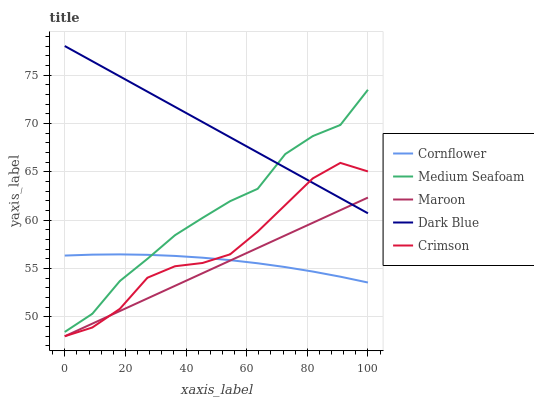Does Maroon have the minimum area under the curve?
Answer yes or no. Yes. Does Dark Blue have the maximum area under the curve?
Answer yes or no. Yes. Does Cornflower have the minimum area under the curve?
Answer yes or no. No. Does Cornflower have the maximum area under the curve?
Answer yes or no. No. Is Maroon the smoothest?
Answer yes or no. Yes. Is Crimson the roughest?
Answer yes or no. Yes. Is Cornflower the smoothest?
Answer yes or no. No. Is Cornflower the roughest?
Answer yes or no. No. Does Cornflower have the lowest value?
Answer yes or no. No. Does Dark Blue have the highest value?
Answer yes or no. Yes. Does Medium Seafoam have the highest value?
Answer yes or no. No. Is Maroon less than Medium Seafoam?
Answer yes or no. Yes. Is Medium Seafoam greater than Crimson?
Answer yes or no. Yes. Does Cornflower intersect Maroon?
Answer yes or no. Yes. Is Cornflower less than Maroon?
Answer yes or no. No. Is Cornflower greater than Maroon?
Answer yes or no. No. Does Maroon intersect Medium Seafoam?
Answer yes or no. No. 